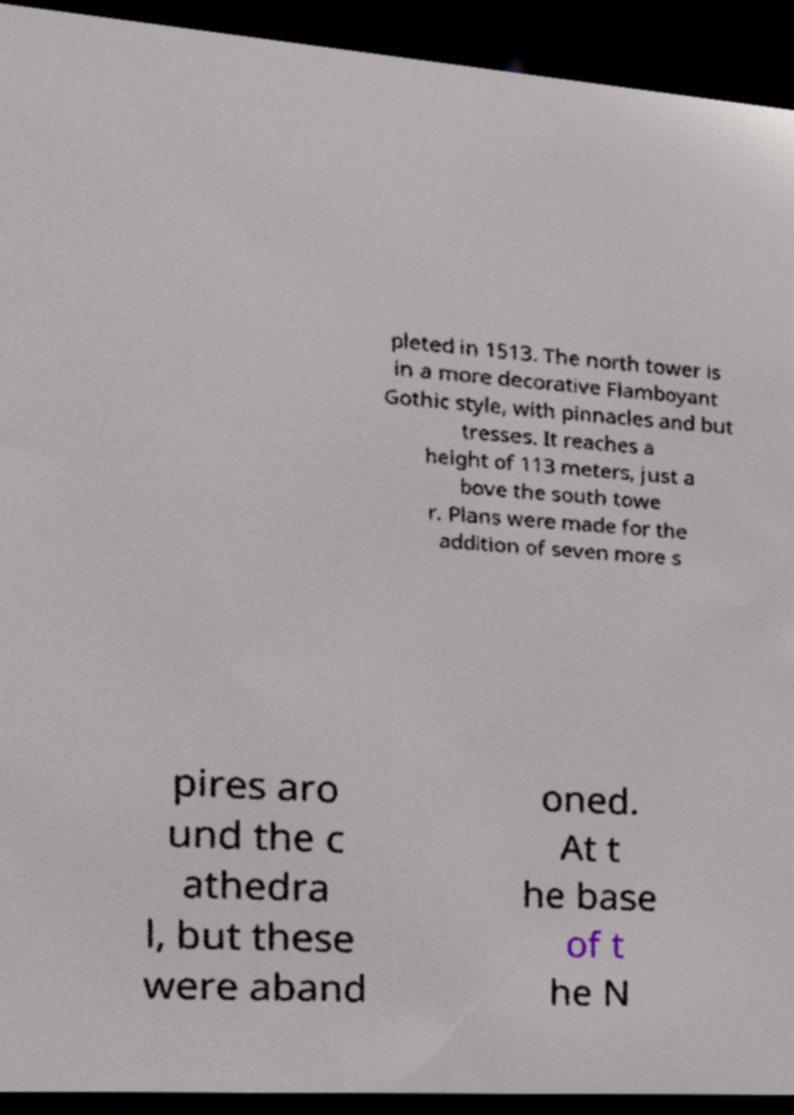What messages or text are displayed in this image? I need them in a readable, typed format. pleted in 1513. The north tower is in a more decorative Flamboyant Gothic style, with pinnacles and but tresses. It reaches a height of 113 meters, just a bove the south towe r. Plans were made for the addition of seven more s pires aro und the c athedra l, but these were aband oned. At t he base of t he N 